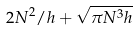Convert formula to latex. <formula><loc_0><loc_0><loc_500><loc_500>2 N ^ { 2 } / h + \sqrt { \pi N ^ { 3 } h }</formula> 